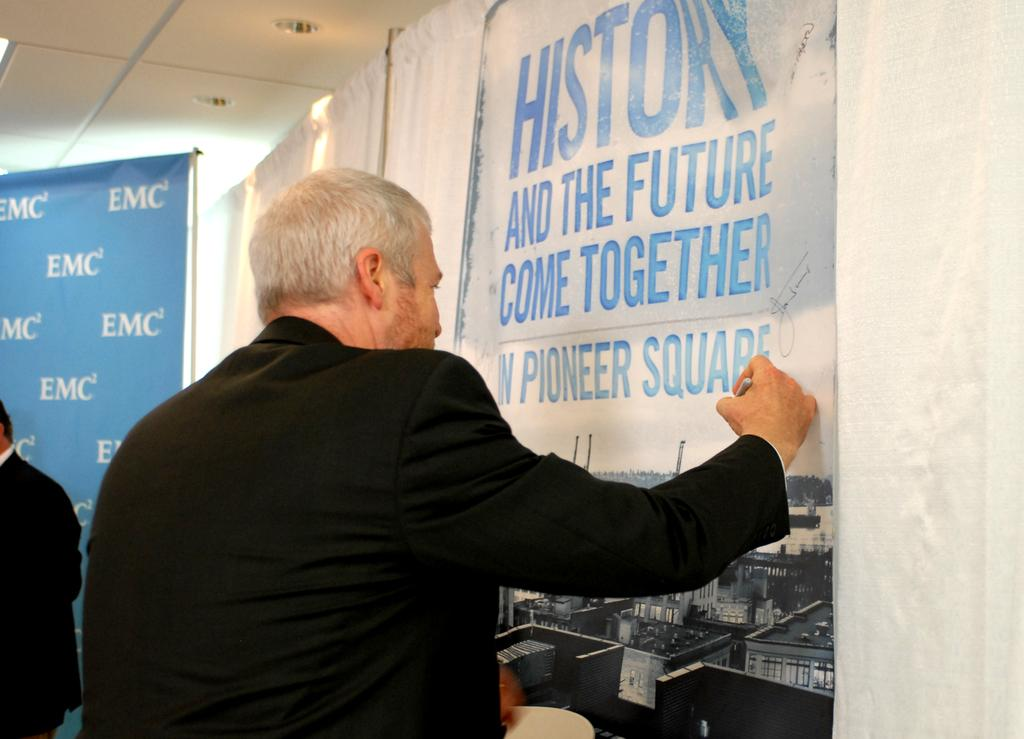<image>
Offer a succinct explanation of the picture presented. Man in a black suit putting his hand on a poster that reads history and the future come together. 